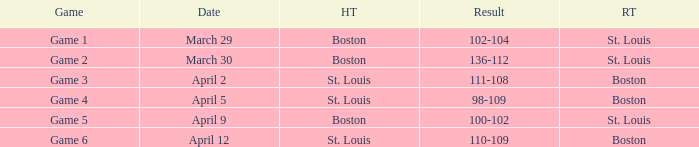What is the Game number on April 12 with St. Louis Home Team? Game 6. 